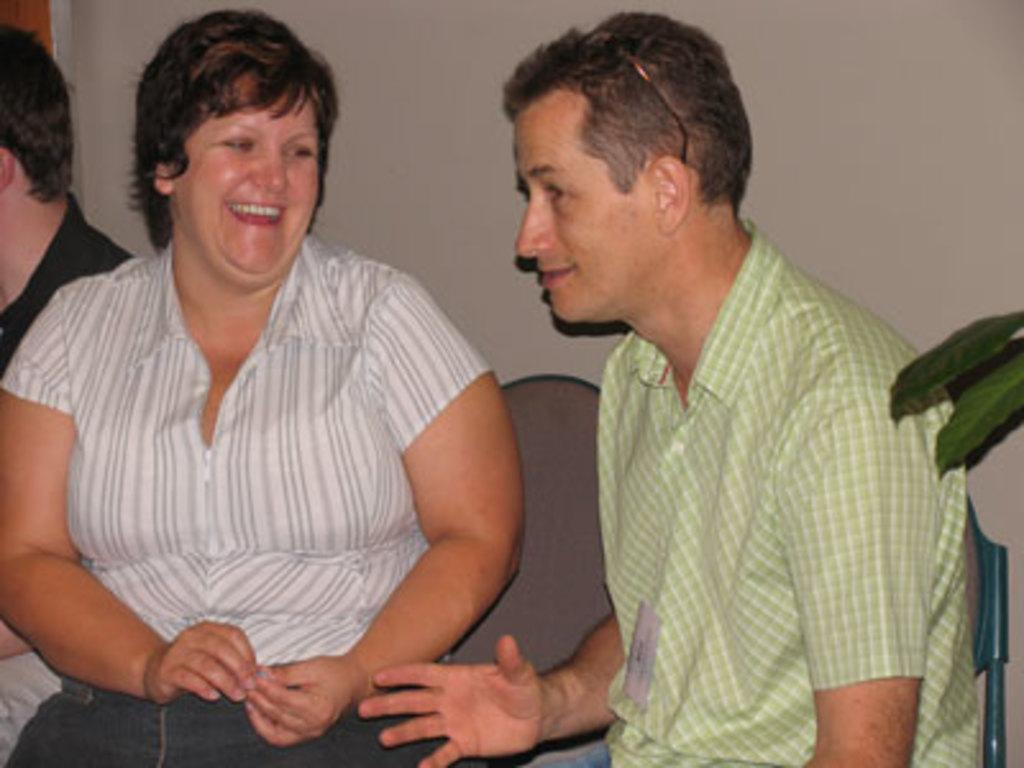How many people are in the image? There are three people in the image. What can be observed about the clothing of the people in the image? The people are wearing different color dresses. What is the facial expression of the people in the image? Two of the people are smiling. What type of vegetation is visible in the image? There are leaves of a plant visible in the image. What is in the background of the image? There is a wall in the background of the image. What type of scarecrow is standing next to the wall in the image? There is no scarecrow present in the image; it features three people wearing different color dresses. How many elbows can be seen in the image? The number of elbows cannot be determined from the image, as it only shows the people from the waist up. 